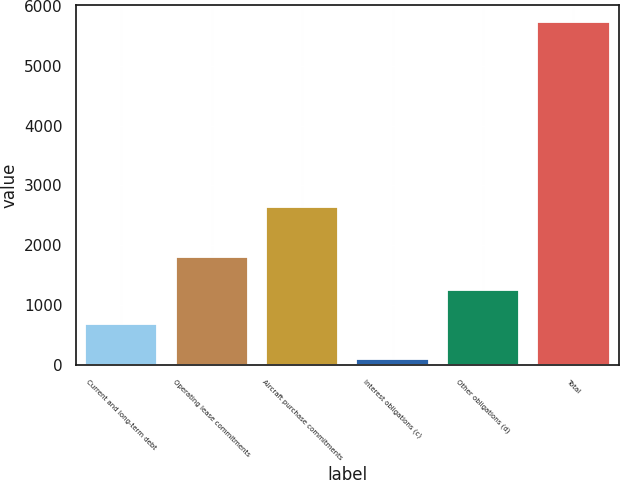<chart> <loc_0><loc_0><loc_500><loc_500><bar_chart><fcel>Current and long-term debt<fcel>Operating lease commitments<fcel>Aircraft purchase commitments<fcel>Interest obligations (c)<fcel>Other obligations (d)<fcel>Total<nl><fcel>686<fcel>1811<fcel>2633<fcel>105<fcel>1248.5<fcel>5730<nl></chart> 